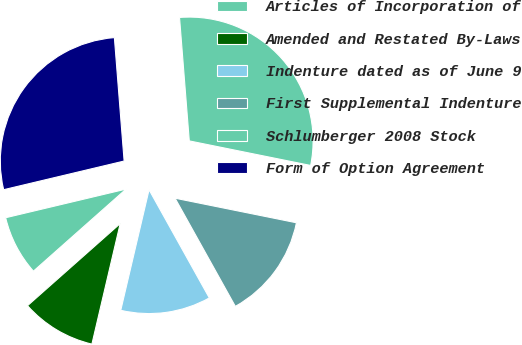<chart> <loc_0><loc_0><loc_500><loc_500><pie_chart><fcel>Articles of Incorporation of<fcel>Amended and Restated By-Laws<fcel>Indenture dated as of June 9<fcel>First Supplemental Indenture<fcel>Schlumberger 2008 Stock<fcel>Form of Option Agreement<nl><fcel>7.82%<fcel>9.79%<fcel>11.76%<fcel>13.73%<fcel>29.43%<fcel>27.46%<nl></chart> 